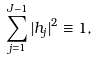<formula> <loc_0><loc_0><loc_500><loc_500>\sum _ { j = 1 } ^ { J - 1 } | h _ { j } | ^ { 2 } \equiv 1 ,</formula> 